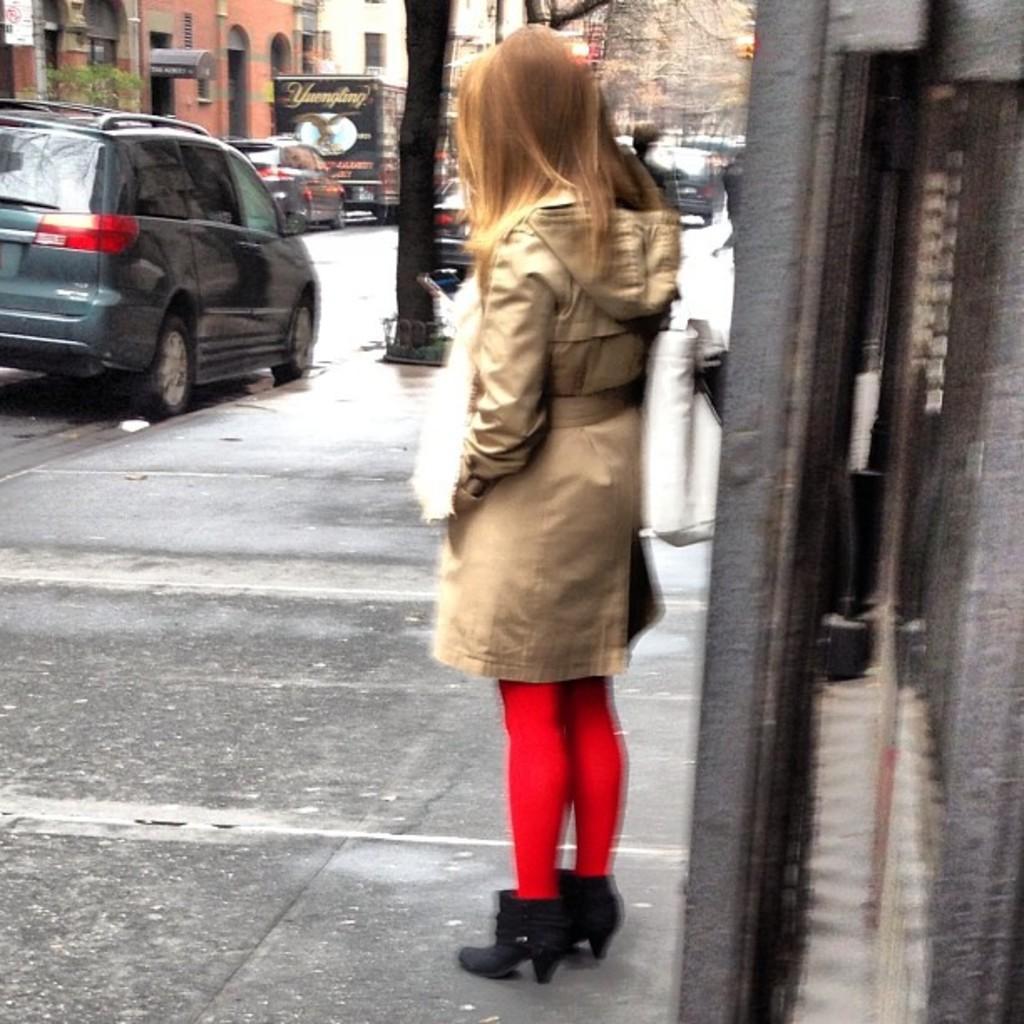Describe this image in one or two sentences. In this image we can see there is a girl standing in front of the building, behind that there are cars also there are buildings on either side. 